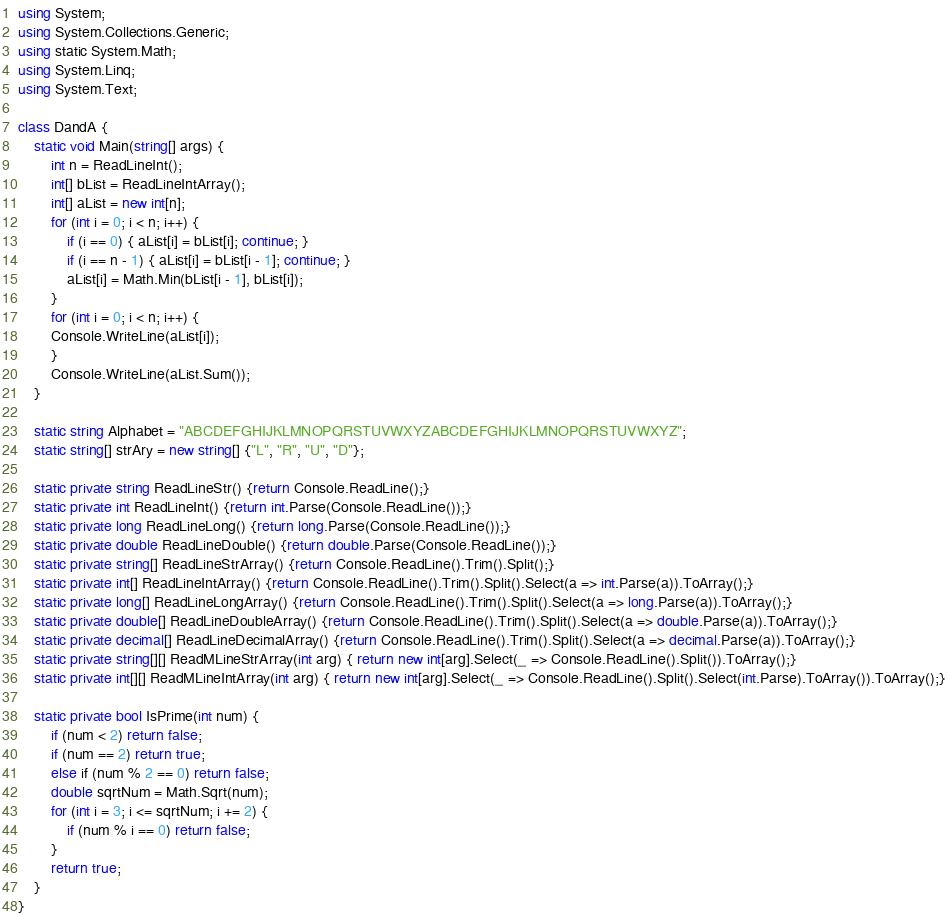Convert code to text. <code><loc_0><loc_0><loc_500><loc_500><_C#_>using System;
using System.Collections.Generic;
using static System.Math;
using System.Linq;
using System.Text;
 
class DandA {
    static void Main(string[] args) {
        int n = ReadLineInt();
        int[] bList = ReadLineIntArray();
        int[] aList = new int[n];
        for (int i = 0; i < n; i++) {
            if (i == 0) { aList[i] = bList[i]; continue; }
            if (i == n - 1) { aList[i] = bList[i - 1]; continue; }
            aList[i] = Math.Min(bList[i - 1], bList[i]);
        }
        for (int i = 0; i < n; i++) {
        Console.WriteLine(aList[i]);
        }
        Console.WriteLine(aList.Sum());
    }
 
    static string Alphabet = "ABCDEFGHIJKLMNOPQRSTUVWXYZABCDEFGHIJKLMNOPQRSTUVWXYZ";
    static string[] strAry = new string[] {"L", "R", "U", "D"}; 
  
    static private string ReadLineStr() {return Console.ReadLine();}
    static private int ReadLineInt() {return int.Parse(Console.ReadLine());}
    static private long ReadLineLong() {return long.Parse(Console.ReadLine());}
    static private double ReadLineDouble() {return double.Parse(Console.ReadLine());}
    static private string[] ReadLineStrArray() {return Console.ReadLine().Trim().Split();}
    static private int[] ReadLineIntArray() {return Console.ReadLine().Trim().Split().Select(a => int.Parse(a)).ToArray();}
    static private long[] ReadLineLongArray() {return Console.ReadLine().Trim().Split().Select(a => long.Parse(a)).ToArray();}
    static private double[] ReadLineDoubleArray() {return Console.ReadLine().Trim().Split().Select(a => double.Parse(a)).ToArray();}
    static private decimal[] ReadLineDecimalArray() {return Console.ReadLine().Trim().Split().Select(a => decimal.Parse(a)).ToArray();}
    static private string[][] ReadMLineStrArray(int arg) { return new int[arg].Select(_ => Console.ReadLine().Split()).ToArray();}
    static private int[][] ReadMLineIntArray(int arg) { return new int[arg].Select(_ => Console.ReadLine().Split().Select(int.Parse).ToArray()).ToArray();}
 
    static private bool IsPrime(int num) {
        if (num < 2) return false;
        if (num == 2) return true;
        else if (num % 2 == 0) return false;
        double sqrtNum = Math.Sqrt(num);
        for (int i = 3; i <= sqrtNum; i += 2) {
            if (num % i == 0) return false;
        }
        return true;
    }
}</code> 